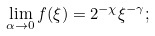<formula> <loc_0><loc_0><loc_500><loc_500>\lim _ { \alpha \to 0 } f ( \xi ) = 2 ^ { - \chi } \xi ^ { - \gamma } ;</formula> 